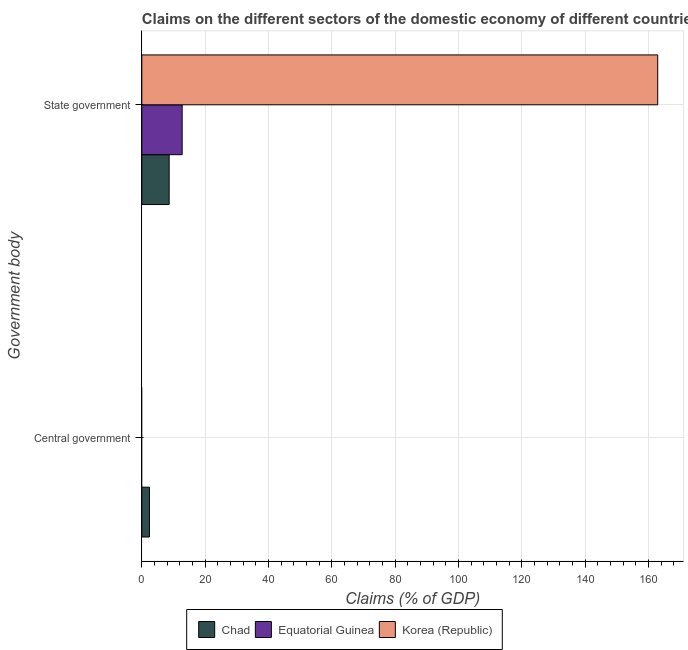Are the number of bars on each tick of the Y-axis equal?
Make the answer very short. No. What is the label of the 1st group of bars from the top?
Ensure brevity in your answer.  State government. Across all countries, what is the maximum claims on central government?
Your answer should be very brief. 2.41. Across all countries, what is the minimum claims on state government?
Your answer should be compact. 8.64. In which country was the claims on central government maximum?
Your answer should be compact. Chad. What is the total claims on central government in the graph?
Keep it short and to the point. 2.41. What is the difference between the claims on state government in Equatorial Guinea and that in Chad?
Offer a very short reply. 4.1. What is the difference between the claims on central government in Chad and the claims on state government in Equatorial Guinea?
Offer a very short reply. -10.34. What is the average claims on state government per country?
Keep it short and to the point. 61.44. What is the difference between the claims on state government and claims on central government in Chad?
Your answer should be very brief. 6.24. In how many countries, is the claims on central government greater than 104 %?
Your response must be concise. 0. What is the ratio of the claims on state government in Equatorial Guinea to that in Korea (Republic)?
Provide a succinct answer. 0.08. In how many countries, is the claims on state government greater than the average claims on state government taken over all countries?
Provide a succinct answer. 1. How many countries are there in the graph?
Ensure brevity in your answer.  3. Are the values on the major ticks of X-axis written in scientific E-notation?
Your answer should be very brief. No. Where does the legend appear in the graph?
Give a very brief answer. Bottom center. How many legend labels are there?
Your answer should be very brief. 3. How are the legend labels stacked?
Provide a succinct answer. Horizontal. What is the title of the graph?
Offer a very short reply. Claims on the different sectors of the domestic economy of different countries. Does "Mexico" appear as one of the legend labels in the graph?
Offer a very short reply. No. What is the label or title of the X-axis?
Make the answer very short. Claims (% of GDP). What is the label or title of the Y-axis?
Your answer should be very brief. Government body. What is the Claims (% of GDP) in Chad in Central government?
Your answer should be very brief. 2.41. What is the Claims (% of GDP) of Korea (Republic) in Central government?
Offer a terse response. 0. What is the Claims (% of GDP) in Chad in State government?
Offer a very short reply. 8.64. What is the Claims (% of GDP) of Equatorial Guinea in State government?
Your answer should be compact. 12.74. What is the Claims (% of GDP) in Korea (Republic) in State government?
Ensure brevity in your answer.  162.93. Across all Government body, what is the maximum Claims (% of GDP) in Chad?
Offer a terse response. 8.64. Across all Government body, what is the maximum Claims (% of GDP) of Equatorial Guinea?
Provide a short and direct response. 12.74. Across all Government body, what is the maximum Claims (% of GDP) of Korea (Republic)?
Your answer should be compact. 162.93. Across all Government body, what is the minimum Claims (% of GDP) of Chad?
Offer a very short reply. 2.41. What is the total Claims (% of GDP) of Chad in the graph?
Your answer should be very brief. 11.05. What is the total Claims (% of GDP) in Equatorial Guinea in the graph?
Offer a terse response. 12.74. What is the total Claims (% of GDP) in Korea (Republic) in the graph?
Your response must be concise. 162.93. What is the difference between the Claims (% of GDP) in Chad in Central government and that in State government?
Your response must be concise. -6.24. What is the difference between the Claims (% of GDP) in Chad in Central government and the Claims (% of GDP) in Equatorial Guinea in State government?
Provide a short and direct response. -10.34. What is the difference between the Claims (% of GDP) of Chad in Central government and the Claims (% of GDP) of Korea (Republic) in State government?
Make the answer very short. -160.53. What is the average Claims (% of GDP) in Chad per Government body?
Keep it short and to the point. 5.52. What is the average Claims (% of GDP) in Equatorial Guinea per Government body?
Ensure brevity in your answer.  6.37. What is the average Claims (% of GDP) in Korea (Republic) per Government body?
Provide a succinct answer. 81.47. What is the difference between the Claims (% of GDP) in Chad and Claims (% of GDP) in Equatorial Guinea in State government?
Offer a very short reply. -4.1. What is the difference between the Claims (% of GDP) in Chad and Claims (% of GDP) in Korea (Republic) in State government?
Your answer should be compact. -154.29. What is the difference between the Claims (% of GDP) in Equatorial Guinea and Claims (% of GDP) in Korea (Republic) in State government?
Offer a very short reply. -150.19. What is the ratio of the Claims (% of GDP) in Chad in Central government to that in State government?
Offer a very short reply. 0.28. What is the difference between the highest and the second highest Claims (% of GDP) of Chad?
Your response must be concise. 6.24. What is the difference between the highest and the lowest Claims (% of GDP) of Chad?
Your answer should be very brief. 6.24. What is the difference between the highest and the lowest Claims (% of GDP) of Equatorial Guinea?
Ensure brevity in your answer.  12.74. What is the difference between the highest and the lowest Claims (% of GDP) in Korea (Republic)?
Keep it short and to the point. 162.93. 